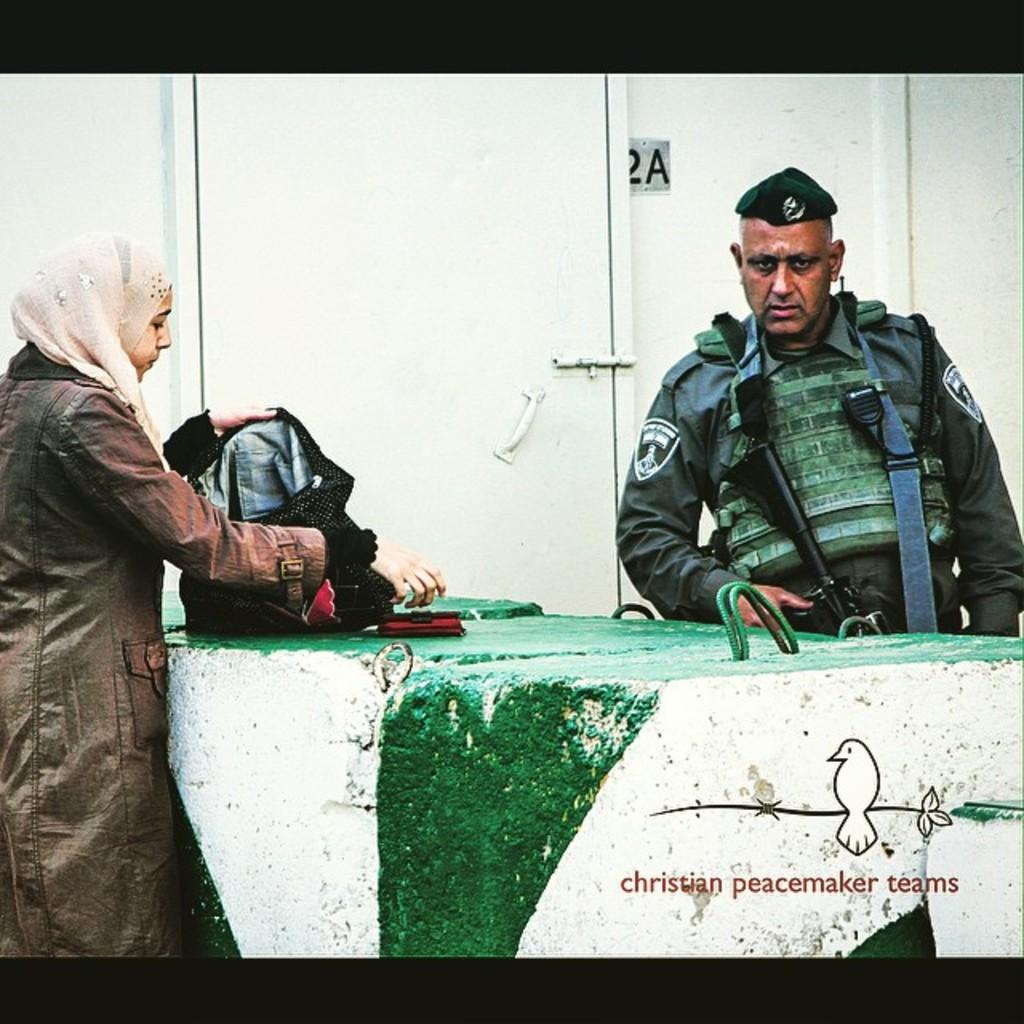How many people are in the image? There are two persons in the image. Can you describe the position of the woman in the image? The woman is on the left side of the image. And where is the man located in the image? The man is on the right side of the image. What can be seen in the middle of the image? There is a door in the middle of the image. What type of coat is the band wearing in the image? There is no band or coat present in the image. How many boys are visible in the image? The image only features two people, a man and a woman, so there are no boys visible. 